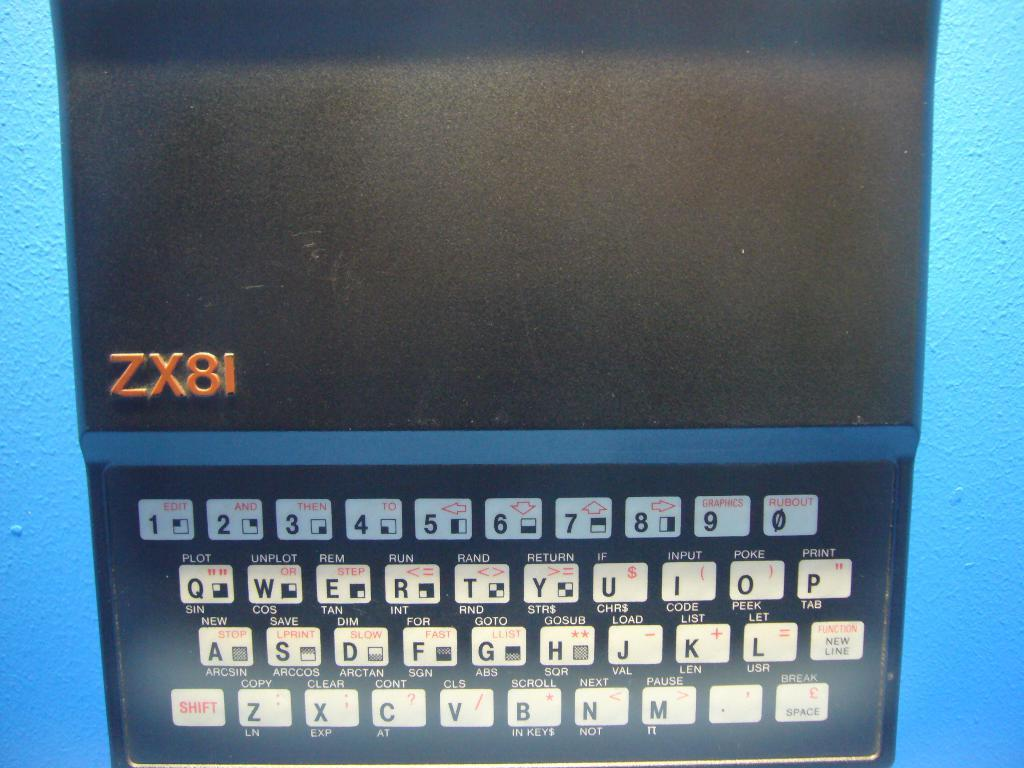<image>
Share a concise interpretation of the image provided. A device on a blue background with ZX81 on the screen. 